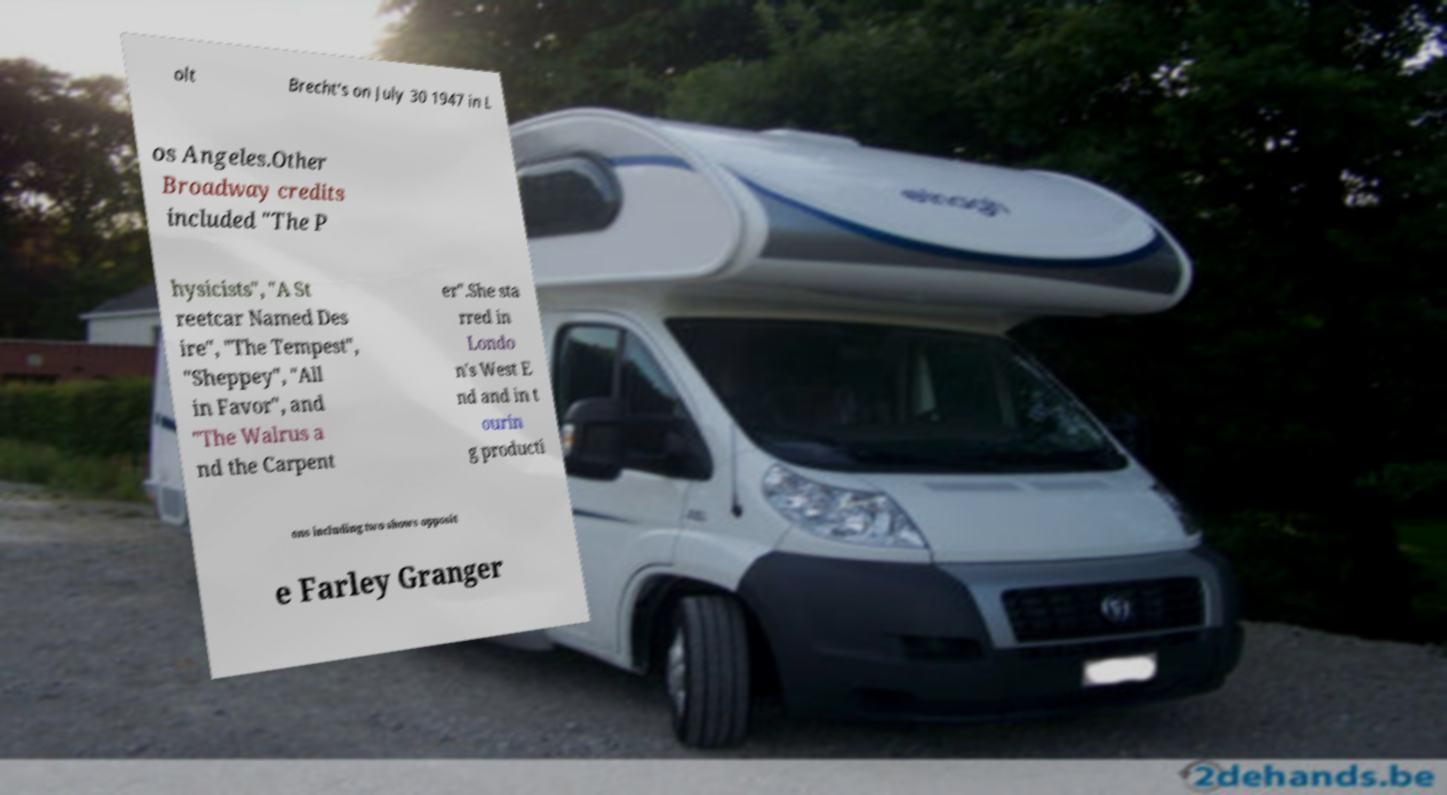Could you assist in decoding the text presented in this image and type it out clearly? olt Brecht's on July 30 1947 in L os Angeles.Other Broadway credits included "The P hysicists", "A St reetcar Named Des ire", "The Tempest", "Sheppey", "All in Favor", and "The Walrus a nd the Carpent er".She sta rred in Londo n's West E nd and in t ourin g producti ons including two shows opposit e Farley Granger 